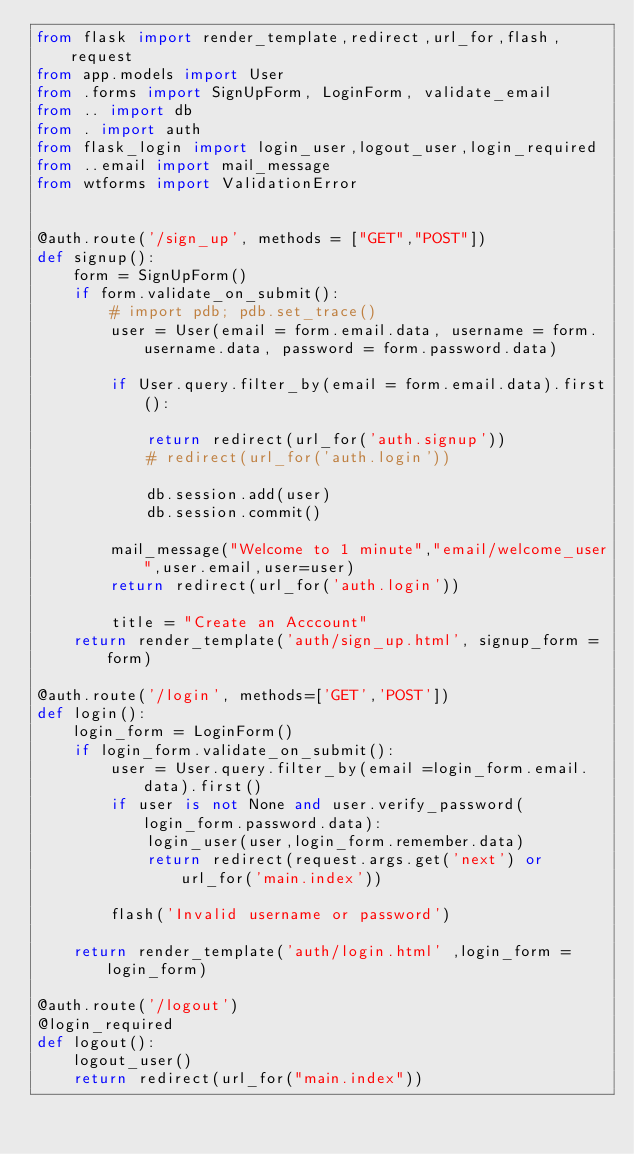Convert code to text. <code><loc_0><loc_0><loc_500><loc_500><_Python_>from flask import render_template,redirect,url_for,flash,request
from app.models import User
from .forms import SignUpForm, LoginForm, validate_email
from .. import db
from . import auth
from flask_login import login_user,logout_user,login_required
from ..email import mail_message
from wtforms import ValidationError


@auth.route('/sign_up', methods = ["GET","POST"])
def signup():
    form = SignUpForm()
    if form.validate_on_submit():
        # import pdb; pdb.set_trace()
        user = User(email = form.email.data, username = form.username.data, password = form.password.data)
    
        if User.query.filter_by(email = form.email.data).first():
            
            return redirect(url_for('auth.signup'))
            # redirect(url_for('auth.login'))

            db.session.add(user)
            db.session.commit()

        mail_message("Welcome to 1 minute","email/welcome_user",user.email,user=user)
        return redirect(url_for('auth.login'))
        
        title = "Create an Acccount"
    return render_template('auth/sign_up.html', signup_form = form)

@auth.route('/login', methods=['GET','POST'])
def login():
    login_form = LoginForm()
    if login_form.validate_on_submit():
        user = User.query.filter_by(email =login_form.email.data).first()
        if user is not None and user.verify_password(login_form.password.data):
            login_user(user,login_form.remember.data)
            return redirect(request.args.get('next') or url_for('main.index'))

        flash('Invalid username or password')

    return render_template('auth/login.html' ,login_form = login_form)    

@auth.route('/logout')
@login_required
def logout():
    logout_user()
    return redirect(url_for("main.index"))


    
</code> 